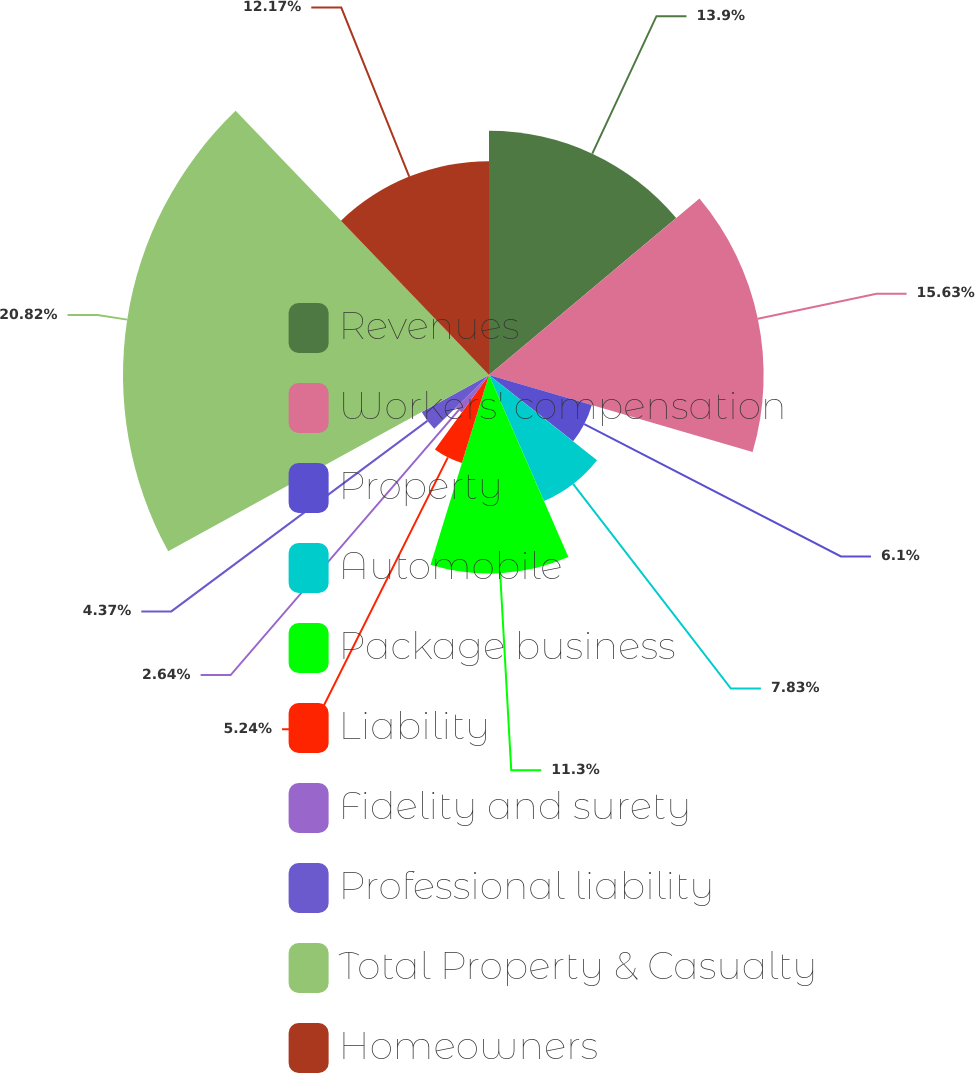Convert chart to OTSL. <chart><loc_0><loc_0><loc_500><loc_500><pie_chart><fcel>Revenues<fcel>Workers' compensation<fcel>Property<fcel>Automobile<fcel>Package business<fcel>Liability<fcel>Fidelity and surety<fcel>Professional liability<fcel>Total Property & Casualty<fcel>Homeowners<nl><fcel>13.9%<fcel>15.63%<fcel>6.1%<fcel>7.83%<fcel>11.3%<fcel>5.24%<fcel>2.64%<fcel>4.37%<fcel>20.83%<fcel>12.17%<nl></chart> 